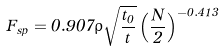Convert formula to latex. <formula><loc_0><loc_0><loc_500><loc_500>F _ { s p } = 0 . 9 0 7 \rho \sqrt { \frac { t _ { 0 } } { t } } \left ( \frac { N } { 2 } \right ) ^ { - 0 . 4 1 3 }</formula> 